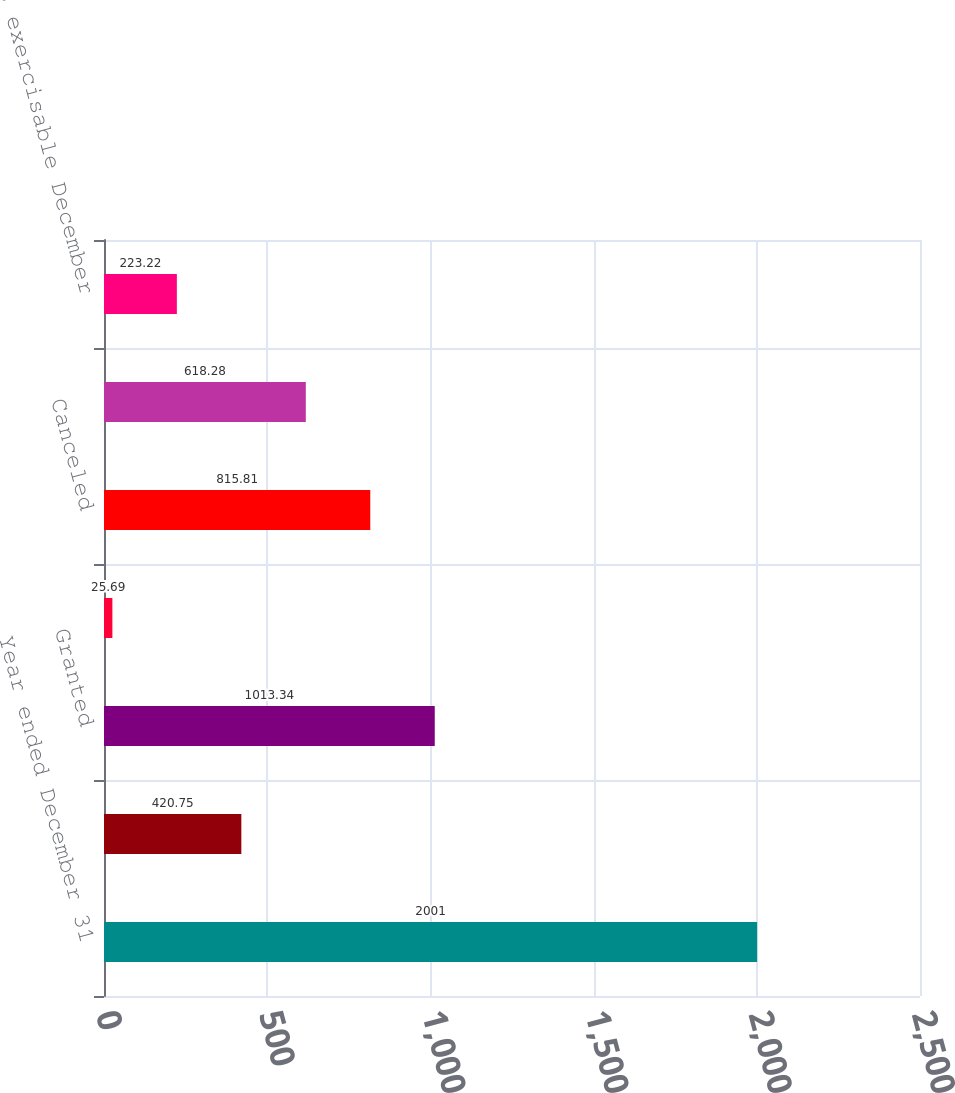Convert chart. <chart><loc_0><loc_0><loc_500><loc_500><bar_chart><fcel>Year ended December 31<fcel>Options outstanding January 1<fcel>Granted<fcel>Exercised<fcel>Canceled<fcel>Options outstanding December<fcel>Options exercisable December<nl><fcel>2001<fcel>420.75<fcel>1013.34<fcel>25.69<fcel>815.81<fcel>618.28<fcel>223.22<nl></chart> 